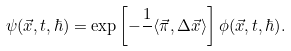<formula> <loc_0><loc_0><loc_500><loc_500>\psi ( \vec { x } , t , \hbar { ) } = \exp \left [ - \frac { 1 } { } \langle \vec { \pi } , \Delta \vec { x } \rangle \right ] \phi ( \vec { x } , t , \hbar { ) } .</formula> 